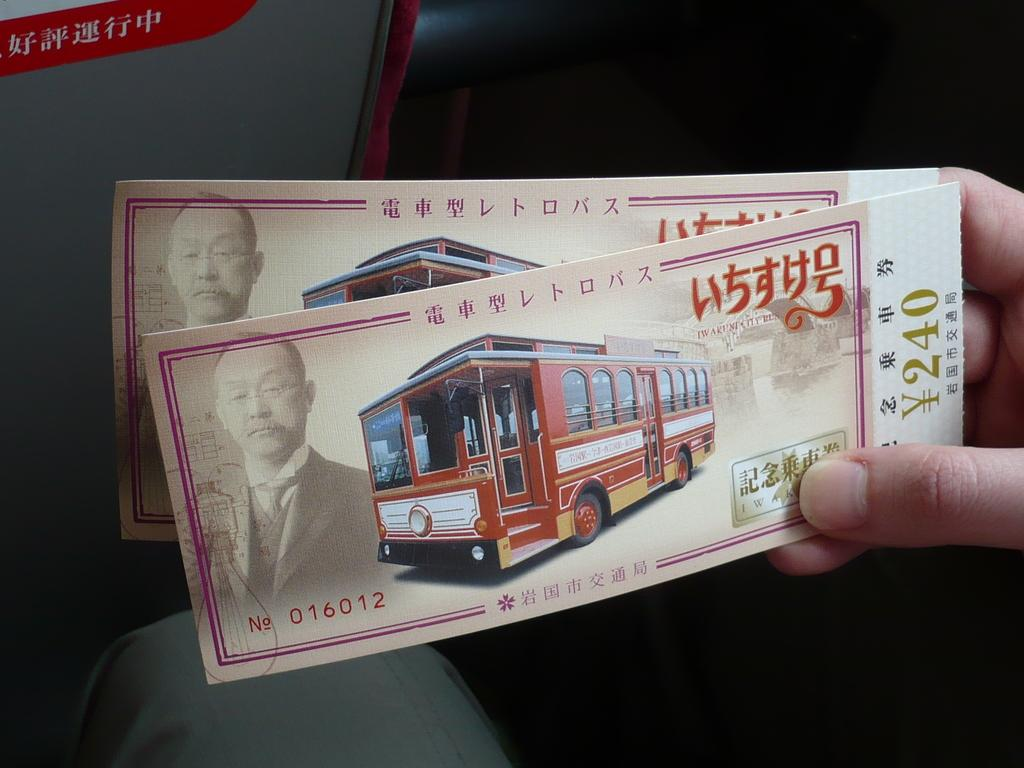What is the person in the image holding? A: The person is holding papers in the image. What can be seen on the papers? The papers contain an image of a vehicle and an image of a person. Are there any words on the papers? Yes, there is writing on the papers. How would you describe the colors in the background of the image? The background of the image has red, grey, and black colors. What type of skirt is the person wearing in the image? There is no skirt visible in the image; the person is holding papers. What is the person's tendency to engage in a specific behavior based on the image? The image does not provide information about the person's behavioral tendencies. 